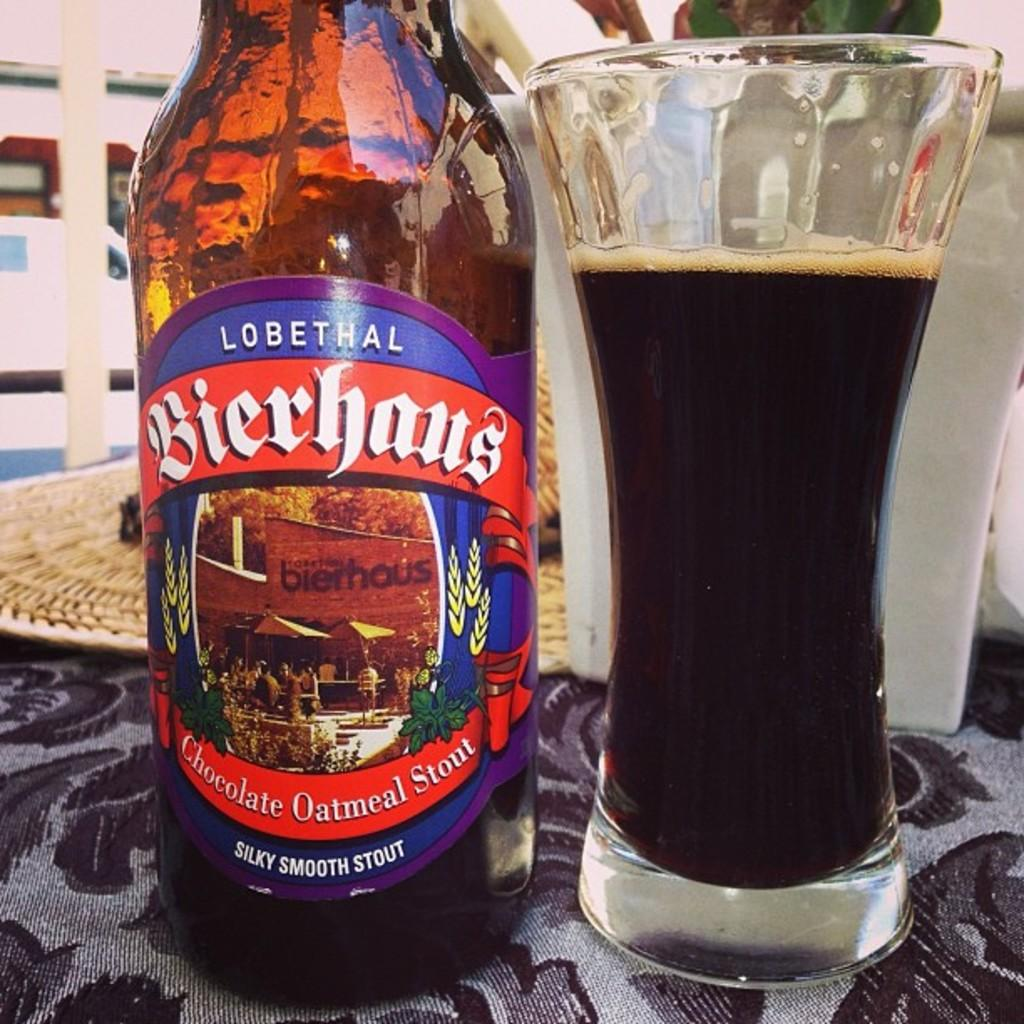<image>
Create a compact narrative representing the image presented. A bottle of Lobethal beer sits beside a nearly full glass of dark beer. 